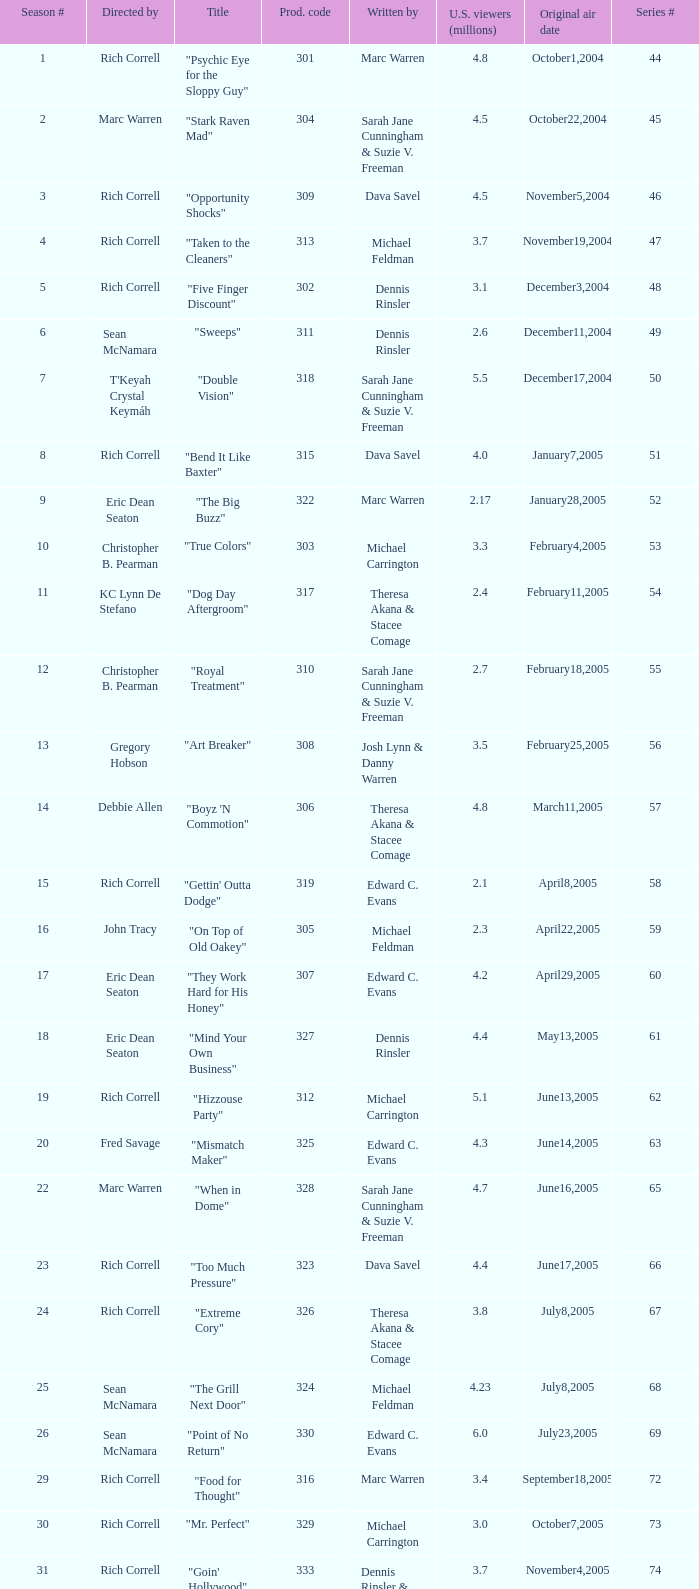What number episode of the season was titled "Vision Impossible"? 34.0. 